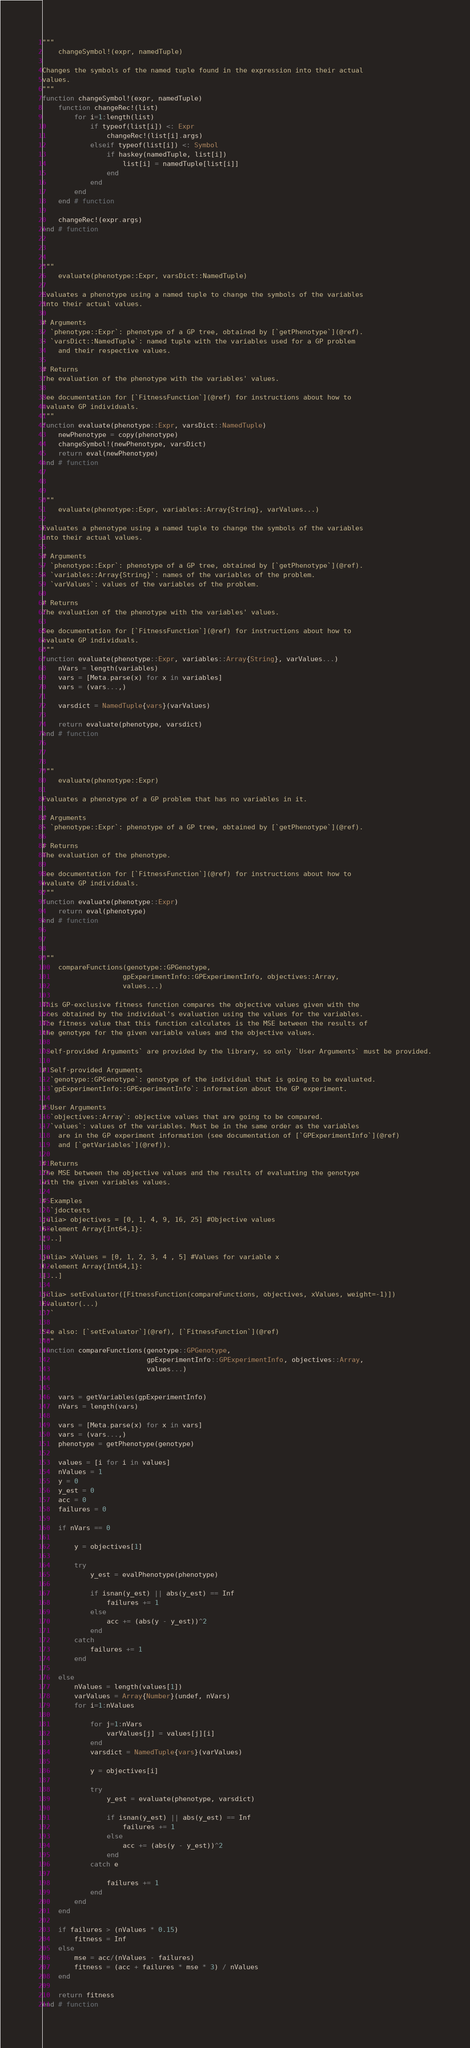<code> <loc_0><loc_0><loc_500><loc_500><_Julia_>"""
    changeSymbol!(expr, namedTuple)

Changes the symbols of the named tuple found in the expression into their actual
values.
"""
function changeSymbol!(expr, namedTuple)
    function changeRec!(list)
        for i=1:length(list)
            if typeof(list[i]) <: Expr
                changeRec!(list[i].args)
            elseif typeof(list[i]) <: Symbol
                if haskey(namedTuple, list[i])
                    list[i] = namedTuple[list[i]]
                end
            end
        end
    end # function

    changeRec!(expr.args)
end # function



"""
    evaluate(phenotype::Expr, varsDict::NamedTuple)

Evaluates a phenotype using a named tuple to change the symbols of the variables
into their actual values.

# Arguments
- `phenotype::Expr`: phenotype of a GP tree, obtained by [`getPhenotype`](@ref).
- `varsDict::NamedTuple`: named tuple with the variables used for a GP problem
    and their respective values.

# Returns
The evaluation of the phenotype with the variables' values.

See documentation for [`FitnessFunction`](@ref) for instructions about how to
evaluate GP individuals.
"""
function evaluate(phenotype::Expr, varsDict::NamedTuple)
    newPhenotype = copy(phenotype)
    changeSymbol!(newPhenotype, varsDict)
    return eval(newPhenotype)
end # function



"""
    evaluate(phenotype::Expr, variables::Array{String}, varValues...)

Evaluates a phenotype using a named tuple to change the symbols of the variables
into their actual values.

# Arguments
- `phenotype::Expr`: phenotype of a GP tree, obtained by [`getPhenotype`](@ref).
- `variables::Array{String}`: names of the variables of the problem.
- `varValues`: values of the variables of the problem.

# Returns
The evaluation of the phenotype with the variables' values.

See documentation for [`FitnessFunction`](@ref) for instructions about how to
evaluate GP individuals.
"""
function evaluate(phenotype::Expr, variables::Array{String}, varValues...)
    nVars = length(variables)
    vars = [Meta.parse(x) for x in variables]
    vars = (vars...,)

    varsdict = NamedTuple{vars}(varValues)

    return evaluate(phenotype, varsdict)
end # function



"""
    evaluate(phenotype::Expr)

Evaluates a phenotype of a GP problem that has no variables in it.

# Arguments
- `phenotype::Expr`: phenotype of a GP tree, obtained by [`getPhenotype`](@ref).

# Returns
The evaluation of the phenotype.

See documentation for [`FitnessFunction`](@ref) for instructions about how to
evaluate GP individuals.
"""
function evaluate(phenotype::Expr)
    return eval(phenotype)
end # function



"""
    compareFunctions(genotype::GPGenotype,
                    gpExperimentInfo::GPExperimentInfo, objectives::Array,
                    values...)

This GP-exclusive fitness function compares the objective values given with the
ones obtained by the individual's evaluation using the values for the variables.
The fitness value that this function calculates is the MSE between the results of
the genotype for the given variable values and the objective values.

`Self-provided Arguments` are provided by the library, so only `User Arguments` must be provided.

# Self-provided Arguments
- `genotype::GPGenotype`: genotype of the individual that is going to be evaluated.
- `gpExperimentInfo::GPExperimentInfo`: information about the GP experiment.

# User Arguments
- `objectives::Array`: objective values that are going to be compared.
- `values`: values of the variables. Must be in the same order as the variables
    are in the GP experiment information (see documentation of [`GPExperimentInfo`](@ref)
    and [`getVariables`](@ref)).

# Returns
The MSE between the objective values and the results of evaluating the genotype
with the given variables values.

# Examples
```jdoctests
julia> objectives = [0, 1, 4, 9, 16, 25] #Objective values
6-element Array{Int64,1}:
[...]

julia> xValues = [0, 1, 2, 3, 4 , 5] #Values for variable x
6-element Array{Int64,1}:
[...]

julia> setEvaluator([FitnessFunction(compareFunctions, objectives, xValues, weight=-1)])
Evaluator(...)
```

See also: [`setEvaluator`](@ref), [`FitnessFunction`](@ref)
"""
function compareFunctions(genotype::GPGenotype,
                          gpExperimentInfo::GPExperimentInfo, objectives::Array,
                          values...)


    vars = getVariables(gpExperimentInfo)
    nVars = length(vars)

    vars = [Meta.parse(x) for x in vars]
    vars = (vars...,)
    phenotype = getPhenotype(genotype)

    values = [i for i in values]
    nValues = 1
    y = 0
    y_est = 0
    acc = 0
    failures = 0

    if nVars == 0

        y = objectives[1]

        try
            y_est = evalPhenotype(phenotype)

            if isnan(y_est) || abs(y_est) == Inf
                failures += 1
            else
                acc += (abs(y - y_est))^2
            end
        catch
            failures += 1
        end

    else
        nValues = length(values[1])
        varValues = Array{Number}(undef, nVars)
        for i=1:nValues

            for j=1:nVars
                varValues[j] = values[j][i]
            end
            varsdict = NamedTuple{vars}(varValues)

            y = objectives[i]

            try
                y_est = evaluate(phenotype, varsdict)

                if isnan(y_est) || abs(y_est) == Inf
                    failures += 1
                else
                    acc += (abs(y - y_est))^2
                end
            catch e

                failures += 1
            end
        end
    end

    if failures > (nValues * 0.15)
        fitness = Inf
    else
        mse = acc/(nValues - failures)
        fitness = (acc + failures * mse * 3) / nValues
    end

    return fitness
end # function
</code> 